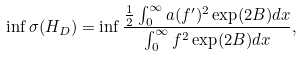Convert formula to latex. <formula><loc_0><loc_0><loc_500><loc_500>\inf \sigma ( H _ { D } ) = \inf \frac { \frac { 1 } { 2 } \int _ { 0 } ^ { \infty } a ( f ^ { \prime } ) ^ { 2 } \exp ( 2 B ) d x } { \int _ { 0 } ^ { \infty } f ^ { 2 } \exp ( 2 B ) d x } ,</formula> 